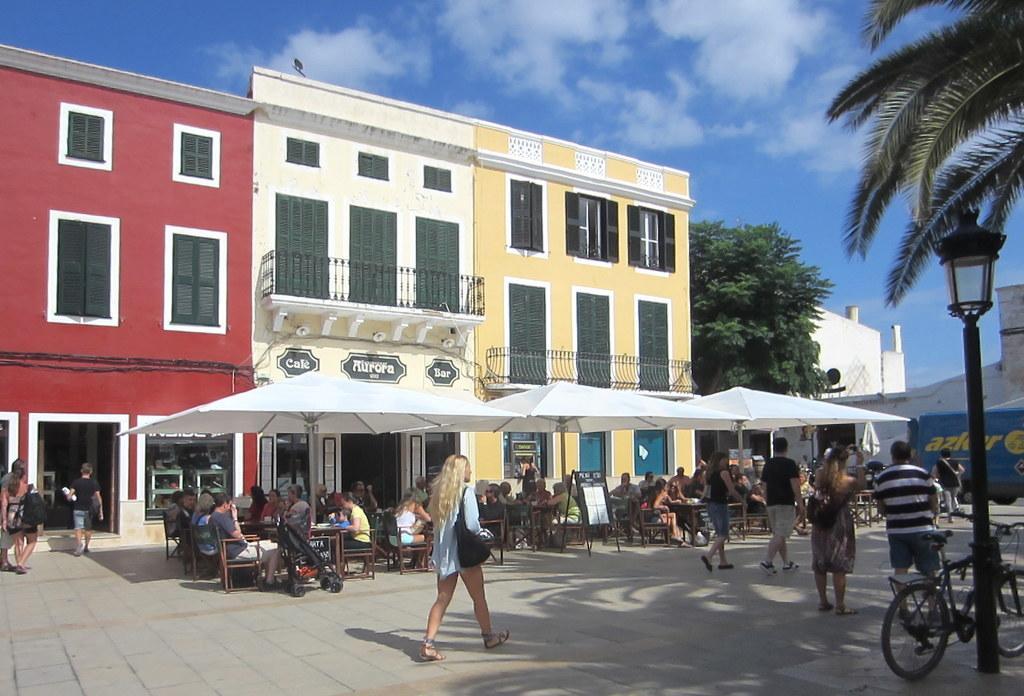Please provide a concise description of this image. In the background of the image there are buildings. In the center of the image three people sitting under umbrellas on chairs. There are people walking on the road. There are trees. At the top of the image there is sky. 